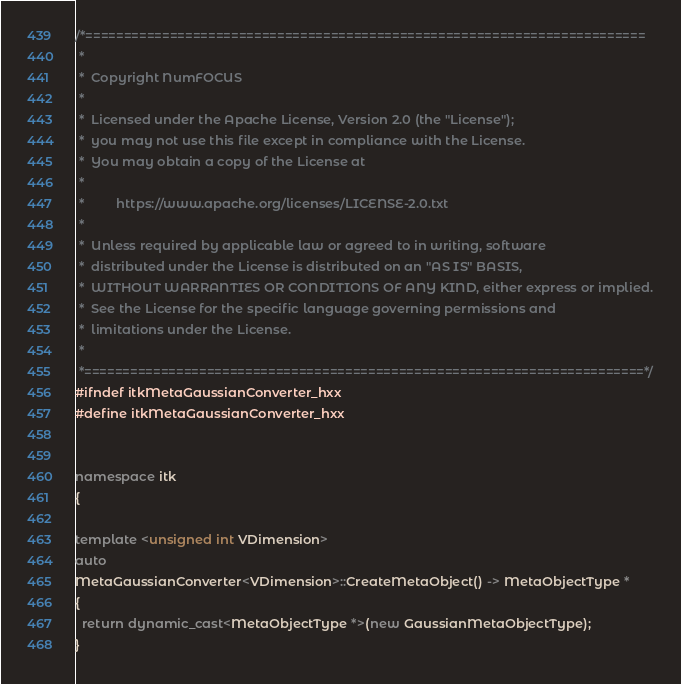<code> <loc_0><loc_0><loc_500><loc_500><_C++_>/*=========================================================================
 *
 *  Copyright NumFOCUS
 *
 *  Licensed under the Apache License, Version 2.0 (the "License");
 *  you may not use this file except in compliance with the License.
 *  You may obtain a copy of the License at
 *
 *         https://www.apache.org/licenses/LICENSE-2.0.txt
 *
 *  Unless required by applicable law or agreed to in writing, software
 *  distributed under the License is distributed on an "AS IS" BASIS,
 *  WITHOUT WARRANTIES OR CONDITIONS OF ANY KIND, either express or implied.
 *  See the License for the specific language governing permissions and
 *  limitations under the License.
 *
 *=========================================================================*/
#ifndef itkMetaGaussianConverter_hxx
#define itkMetaGaussianConverter_hxx


namespace itk
{

template <unsigned int VDimension>
auto
MetaGaussianConverter<VDimension>::CreateMetaObject() -> MetaObjectType *
{
  return dynamic_cast<MetaObjectType *>(new GaussianMetaObjectType);
}
</code> 